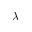Convert formula to latex. <formula><loc_0><loc_0><loc_500><loc_500>\lambda</formula> 